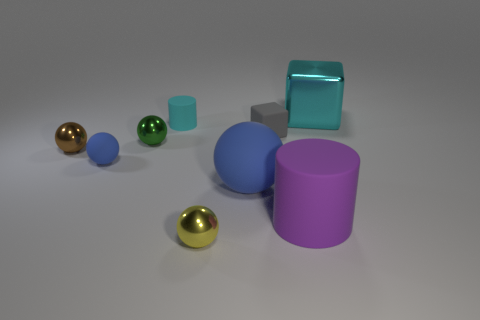Subtract all green balls. How many balls are left? 4 Subtract all tiny blue spheres. How many spheres are left? 4 Add 1 small gray cylinders. How many objects exist? 10 Subtract all red spheres. Subtract all brown cubes. How many spheres are left? 5 Subtract all spheres. How many objects are left? 4 Add 3 red metal balls. How many red metal balls exist? 3 Subtract 0 purple spheres. How many objects are left? 9 Subtract all cyan shiny spheres. Subtract all blocks. How many objects are left? 7 Add 4 purple cylinders. How many purple cylinders are left? 5 